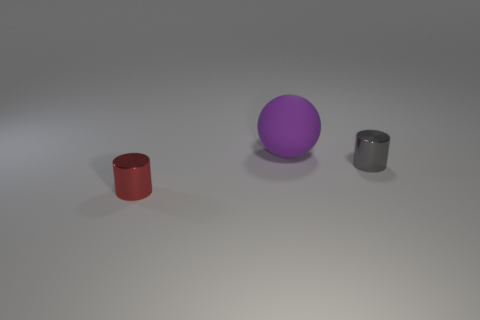Add 3 large rubber objects. How many objects exist? 6 Subtract all cylinders. How many objects are left? 1 Subtract 0 brown blocks. How many objects are left? 3 Subtract all tiny blue matte things. Subtract all red metallic cylinders. How many objects are left? 2 Add 3 gray cylinders. How many gray cylinders are left? 4 Add 3 large rubber objects. How many large rubber objects exist? 4 